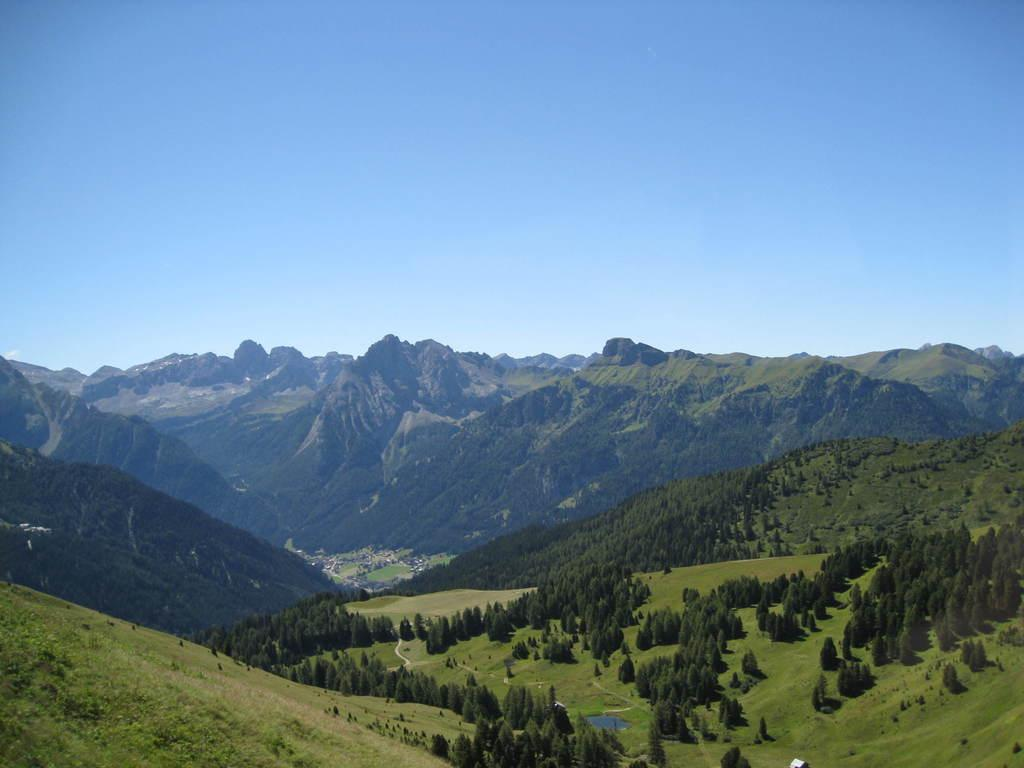What type of natural features can be seen in the image? There are trees and mountains in the image. What part of the natural environment is visible in the image? The sky is visible in the image. What type of floor can be seen in the image? There is no floor present in the image, as it features natural elements such as trees, mountains, and the sky. 